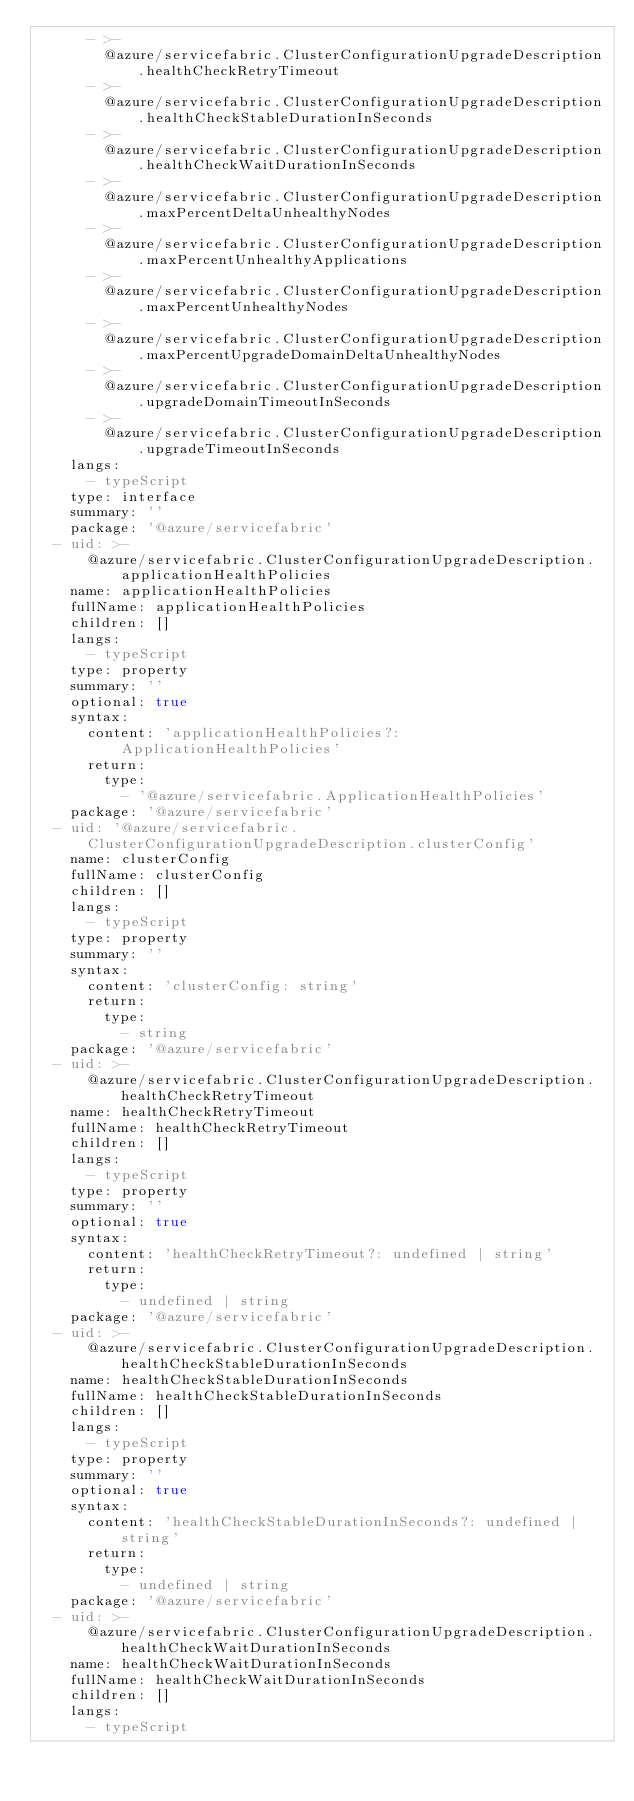<code> <loc_0><loc_0><loc_500><loc_500><_YAML_>      - >-
        @azure/servicefabric.ClusterConfigurationUpgradeDescription.healthCheckRetryTimeout
      - >-
        @azure/servicefabric.ClusterConfigurationUpgradeDescription.healthCheckStableDurationInSeconds
      - >-
        @azure/servicefabric.ClusterConfigurationUpgradeDescription.healthCheckWaitDurationInSeconds
      - >-
        @azure/servicefabric.ClusterConfigurationUpgradeDescription.maxPercentDeltaUnhealthyNodes
      - >-
        @azure/servicefabric.ClusterConfigurationUpgradeDescription.maxPercentUnhealthyApplications
      - >-
        @azure/servicefabric.ClusterConfigurationUpgradeDescription.maxPercentUnhealthyNodes
      - >-
        @azure/servicefabric.ClusterConfigurationUpgradeDescription.maxPercentUpgradeDomainDeltaUnhealthyNodes
      - >-
        @azure/servicefabric.ClusterConfigurationUpgradeDescription.upgradeDomainTimeoutInSeconds
      - >-
        @azure/servicefabric.ClusterConfigurationUpgradeDescription.upgradeTimeoutInSeconds
    langs:
      - typeScript
    type: interface
    summary: ''
    package: '@azure/servicefabric'
  - uid: >-
      @azure/servicefabric.ClusterConfigurationUpgradeDescription.applicationHealthPolicies
    name: applicationHealthPolicies
    fullName: applicationHealthPolicies
    children: []
    langs:
      - typeScript
    type: property
    summary: ''
    optional: true
    syntax:
      content: 'applicationHealthPolicies?: ApplicationHealthPolicies'
      return:
        type:
          - '@azure/servicefabric.ApplicationHealthPolicies'
    package: '@azure/servicefabric'
  - uid: '@azure/servicefabric.ClusterConfigurationUpgradeDescription.clusterConfig'
    name: clusterConfig
    fullName: clusterConfig
    children: []
    langs:
      - typeScript
    type: property
    summary: ''
    syntax:
      content: 'clusterConfig: string'
      return:
        type:
          - string
    package: '@azure/servicefabric'
  - uid: >-
      @azure/servicefabric.ClusterConfigurationUpgradeDescription.healthCheckRetryTimeout
    name: healthCheckRetryTimeout
    fullName: healthCheckRetryTimeout
    children: []
    langs:
      - typeScript
    type: property
    summary: ''
    optional: true
    syntax:
      content: 'healthCheckRetryTimeout?: undefined | string'
      return:
        type:
          - undefined | string
    package: '@azure/servicefabric'
  - uid: >-
      @azure/servicefabric.ClusterConfigurationUpgradeDescription.healthCheckStableDurationInSeconds
    name: healthCheckStableDurationInSeconds
    fullName: healthCheckStableDurationInSeconds
    children: []
    langs:
      - typeScript
    type: property
    summary: ''
    optional: true
    syntax:
      content: 'healthCheckStableDurationInSeconds?: undefined | string'
      return:
        type:
          - undefined | string
    package: '@azure/servicefabric'
  - uid: >-
      @azure/servicefabric.ClusterConfigurationUpgradeDescription.healthCheckWaitDurationInSeconds
    name: healthCheckWaitDurationInSeconds
    fullName: healthCheckWaitDurationInSeconds
    children: []
    langs:
      - typeScript</code> 